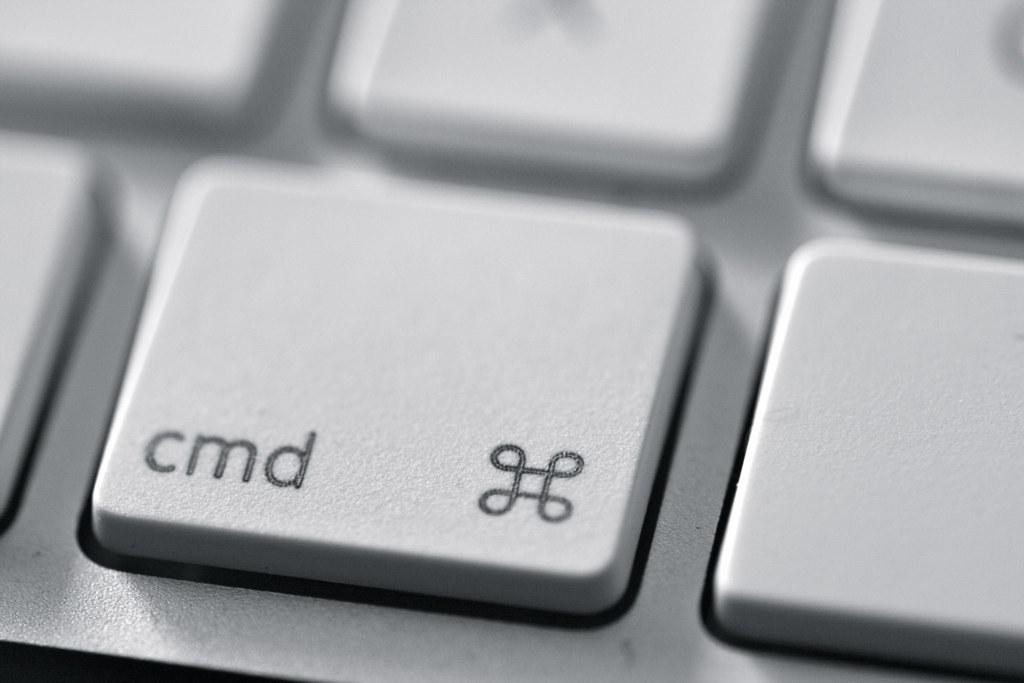<image>
Offer a succinct explanation of the picture presented. A keyboard button has a symbol and the letters cmd on it. 